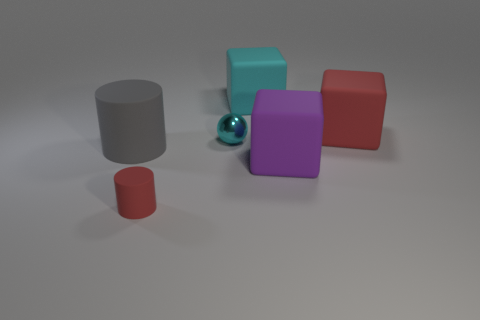What number of large things are behind the red matte thing that is behind the small object that is to the left of the sphere? Behind the red cube, which itself is behind the small red cylinder to the left of the blue sphere, there is one large gray cylinder. 